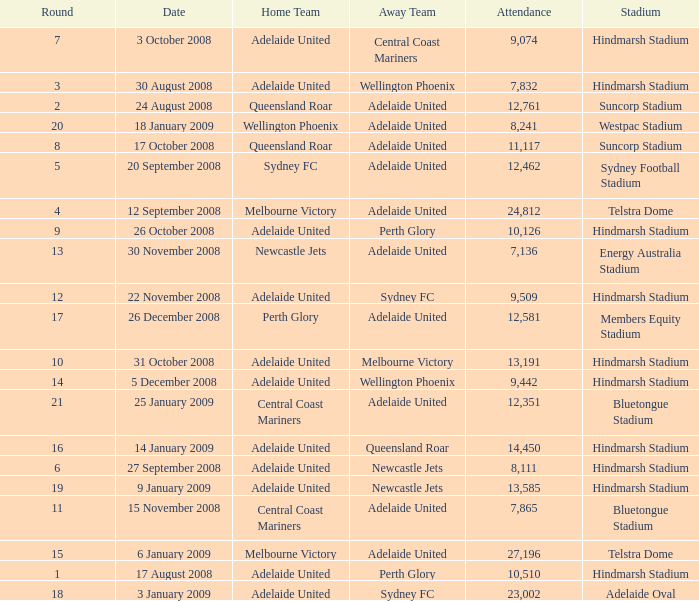What is the round when 11,117 people attended the game on 26 October 2008? 9.0. Could you parse the entire table? {'header': ['Round', 'Date', 'Home Team', 'Away Team', 'Attendance', 'Stadium'], 'rows': [['7', '3 October 2008', 'Adelaide United', 'Central Coast Mariners', '9,074', 'Hindmarsh Stadium'], ['3', '30 August 2008', 'Adelaide United', 'Wellington Phoenix', '7,832', 'Hindmarsh Stadium'], ['2', '24 August 2008', 'Queensland Roar', 'Adelaide United', '12,761', 'Suncorp Stadium'], ['20', '18 January 2009', 'Wellington Phoenix', 'Adelaide United', '8,241', 'Westpac Stadium'], ['8', '17 October 2008', 'Queensland Roar', 'Adelaide United', '11,117', 'Suncorp Stadium'], ['5', '20 September 2008', 'Sydney FC', 'Adelaide United', '12,462', 'Sydney Football Stadium'], ['4', '12 September 2008', 'Melbourne Victory', 'Adelaide United', '24,812', 'Telstra Dome'], ['9', '26 October 2008', 'Adelaide United', 'Perth Glory', '10,126', 'Hindmarsh Stadium'], ['13', '30 November 2008', 'Newcastle Jets', 'Adelaide United', '7,136', 'Energy Australia Stadium'], ['12', '22 November 2008', 'Adelaide United', 'Sydney FC', '9,509', 'Hindmarsh Stadium'], ['17', '26 December 2008', 'Perth Glory', 'Adelaide United', '12,581', 'Members Equity Stadium'], ['10', '31 October 2008', 'Adelaide United', 'Melbourne Victory', '13,191', 'Hindmarsh Stadium'], ['14', '5 December 2008', 'Adelaide United', 'Wellington Phoenix', '9,442', 'Hindmarsh Stadium'], ['21', '25 January 2009', 'Central Coast Mariners', 'Adelaide United', '12,351', 'Bluetongue Stadium'], ['16', '14 January 2009', 'Adelaide United', 'Queensland Roar', '14,450', 'Hindmarsh Stadium'], ['6', '27 September 2008', 'Adelaide United', 'Newcastle Jets', '8,111', 'Hindmarsh Stadium'], ['19', '9 January 2009', 'Adelaide United', 'Newcastle Jets', '13,585', 'Hindmarsh Stadium'], ['11', '15 November 2008', 'Central Coast Mariners', 'Adelaide United', '7,865', 'Bluetongue Stadium'], ['15', '6 January 2009', 'Melbourne Victory', 'Adelaide United', '27,196', 'Telstra Dome'], ['1', '17 August 2008', 'Adelaide United', 'Perth Glory', '10,510', 'Hindmarsh Stadium'], ['18', '3 January 2009', 'Adelaide United', 'Sydney FC', '23,002', 'Adelaide Oval']]} 